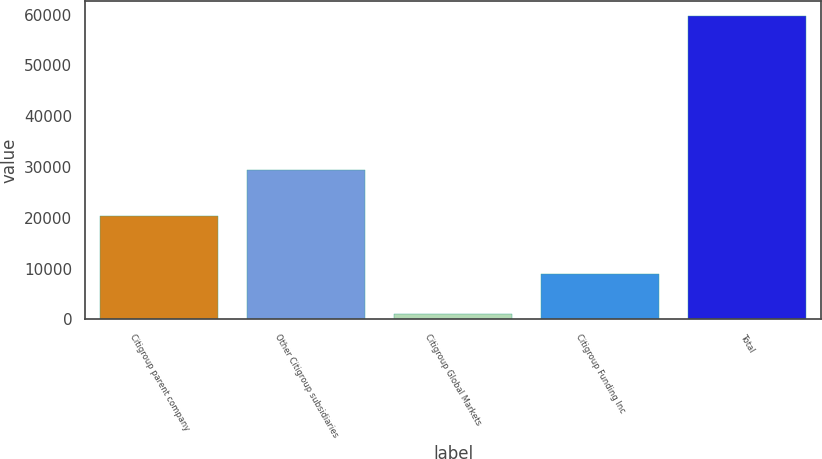Convert chart. <chart><loc_0><loc_0><loc_500><loc_500><bar_chart><fcel>Citigroup parent company<fcel>Other Citigroup subsidiaries<fcel>Citigroup Global Markets<fcel>Citigroup Funding Inc<fcel>Total<nl><fcel>20435<fcel>29316<fcel>1030<fcel>8875<fcel>59656<nl></chart> 